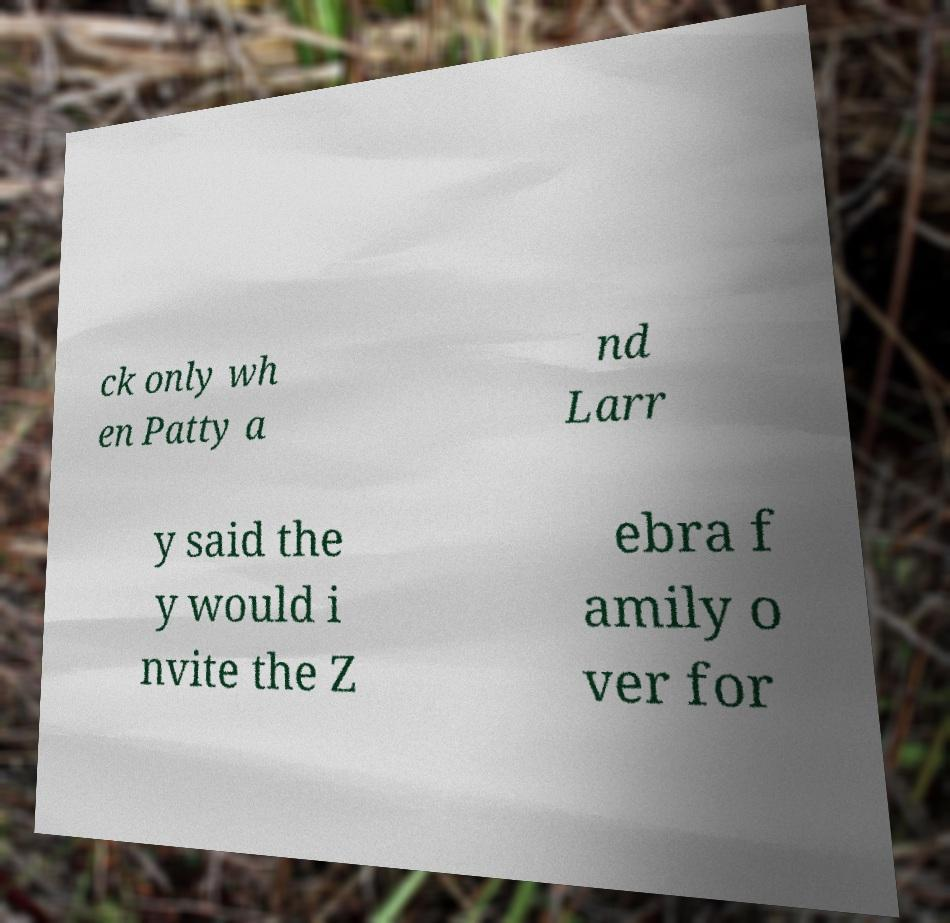Can you read and provide the text displayed in the image?This photo seems to have some interesting text. Can you extract and type it out for me? ck only wh en Patty a nd Larr y said the y would i nvite the Z ebra f amily o ver for 